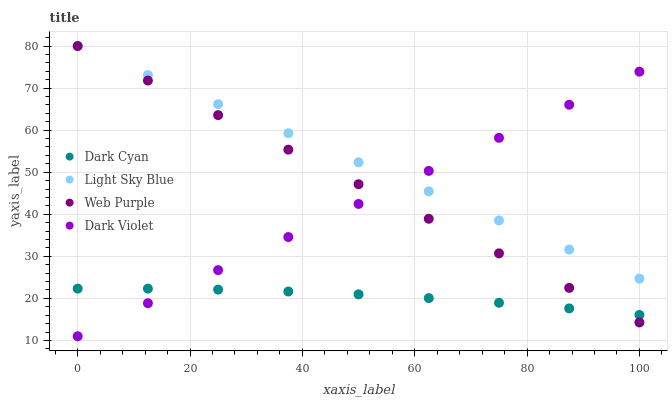Does Dark Cyan have the minimum area under the curve?
Answer yes or no. Yes. Does Light Sky Blue have the maximum area under the curve?
Answer yes or no. Yes. Does Web Purple have the minimum area under the curve?
Answer yes or no. No. Does Web Purple have the maximum area under the curve?
Answer yes or no. No. Is Dark Violet the smoothest?
Answer yes or no. Yes. Is Dark Cyan the roughest?
Answer yes or no. Yes. Is Web Purple the smoothest?
Answer yes or no. No. Is Web Purple the roughest?
Answer yes or no. No. Does Dark Violet have the lowest value?
Answer yes or no. Yes. Does Web Purple have the lowest value?
Answer yes or no. No. Does Light Sky Blue have the highest value?
Answer yes or no. Yes. Does Dark Violet have the highest value?
Answer yes or no. No. Is Dark Cyan less than Light Sky Blue?
Answer yes or no. Yes. Is Light Sky Blue greater than Dark Cyan?
Answer yes or no. Yes. Does Dark Violet intersect Dark Cyan?
Answer yes or no. Yes. Is Dark Violet less than Dark Cyan?
Answer yes or no. No. Is Dark Violet greater than Dark Cyan?
Answer yes or no. No. Does Dark Cyan intersect Light Sky Blue?
Answer yes or no. No. 